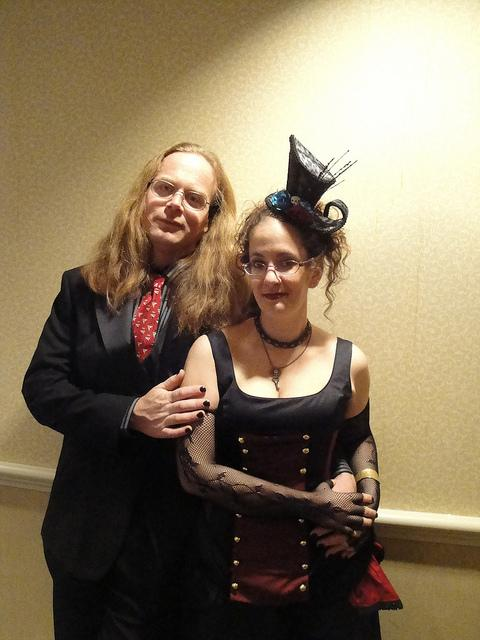Why is the woman wearing a hat? costume 